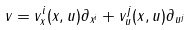<formula> <loc_0><loc_0><loc_500><loc_500>v = v _ { x } ^ { i } ( x , u ) \partial _ { x ^ { i } } + v _ { u } ^ { j } ( x , u ) \partial _ { u ^ { j } }</formula> 